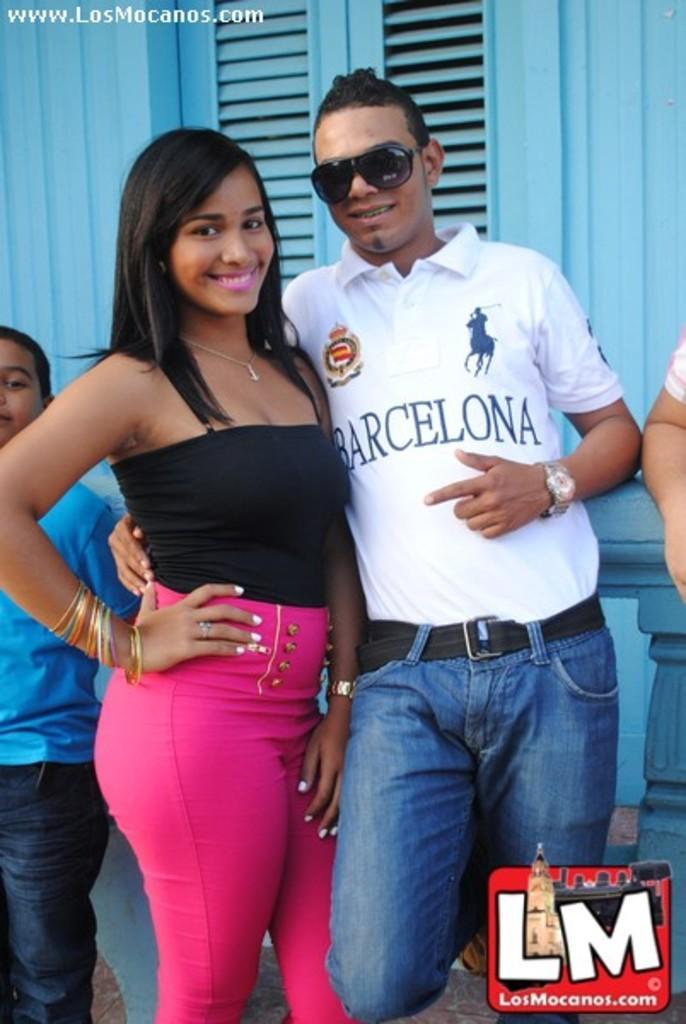In one or two sentences, can you explain what this image depicts? In the image we can see a man and a woman standing, they are wearing clothes, these are the bangles, finger ring, wrist watch, neck chain, goggle and watermark. Even there are other people standing. 